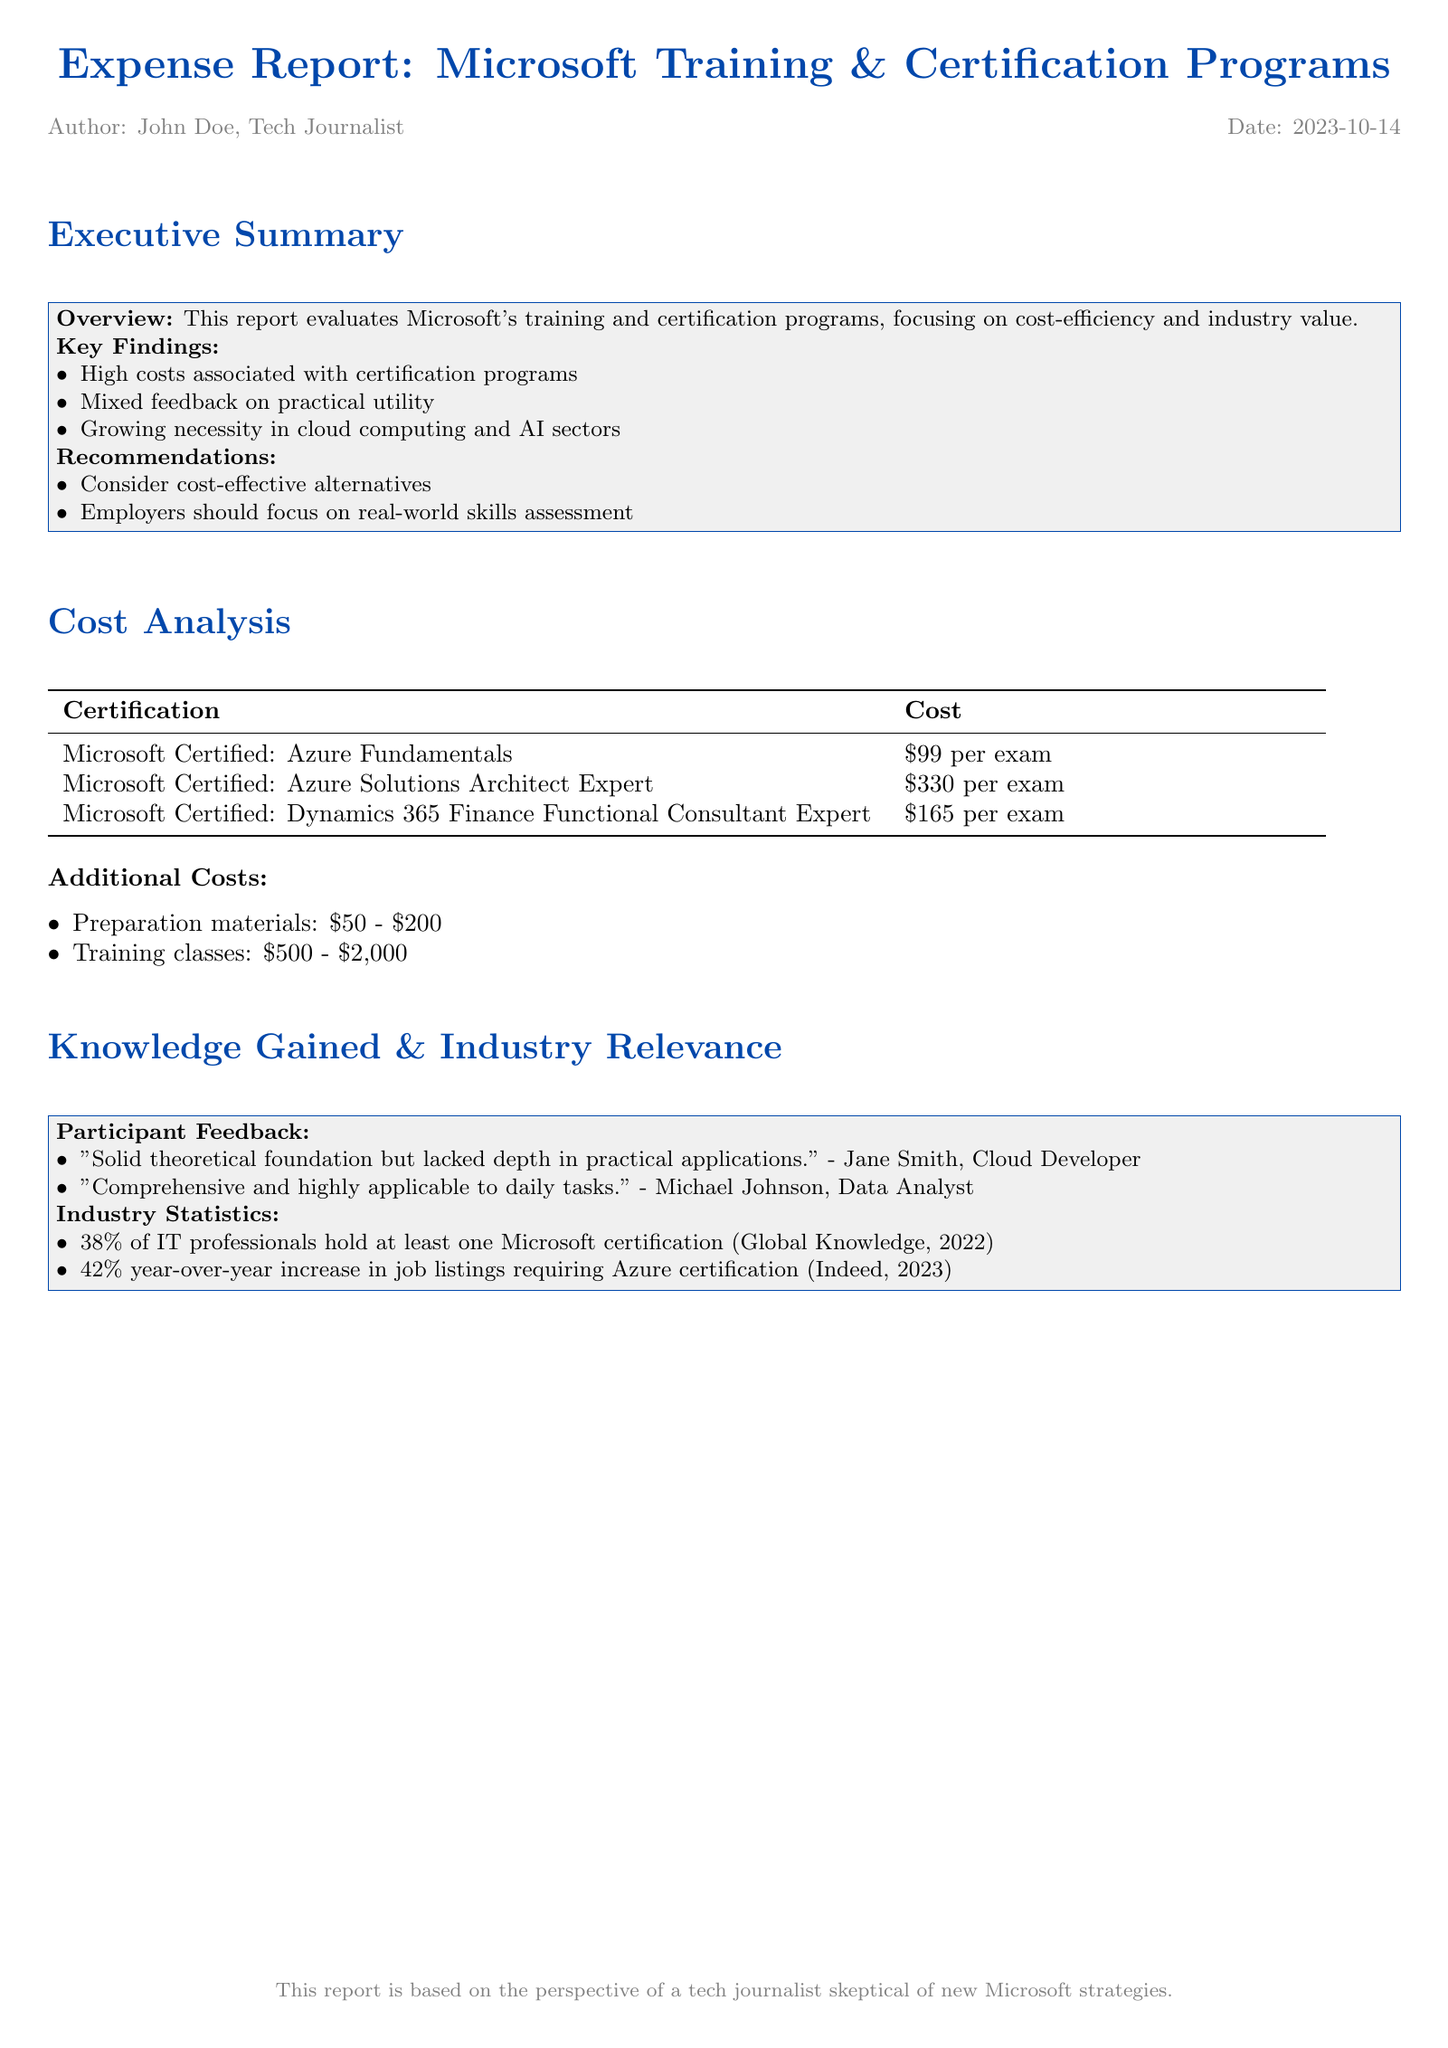What is the cost of the Azure Fundamentals certification? The cost of the Azure Fundamentals certification is detailed in the cost analysis section, which states that it is $99 per exam.
Answer: $99 per exam What percentage of IT professionals hold at least one Microsoft certification? The document provides industry statistics, indicating that 38% of IT professionals hold at least one Microsoft certification.
Answer: 38% What is the range for preparation materials costs? The additional costs section specifies that preparation materials range from $50 to $200.
Answer: $50 - $200 What feedback did Jane Smith provide about the training program? Participant feedback shows that Jane Smith said it had a solid theoretical foundation but lacked depth in practical applications.
Answer: Lacked depth in practical applications What trend is observed in job listings for Azure certification? The industry statistics indicate a 42% year-over-year increase in job listings requiring Azure certification.
Answer: 42% year-over-year increase 